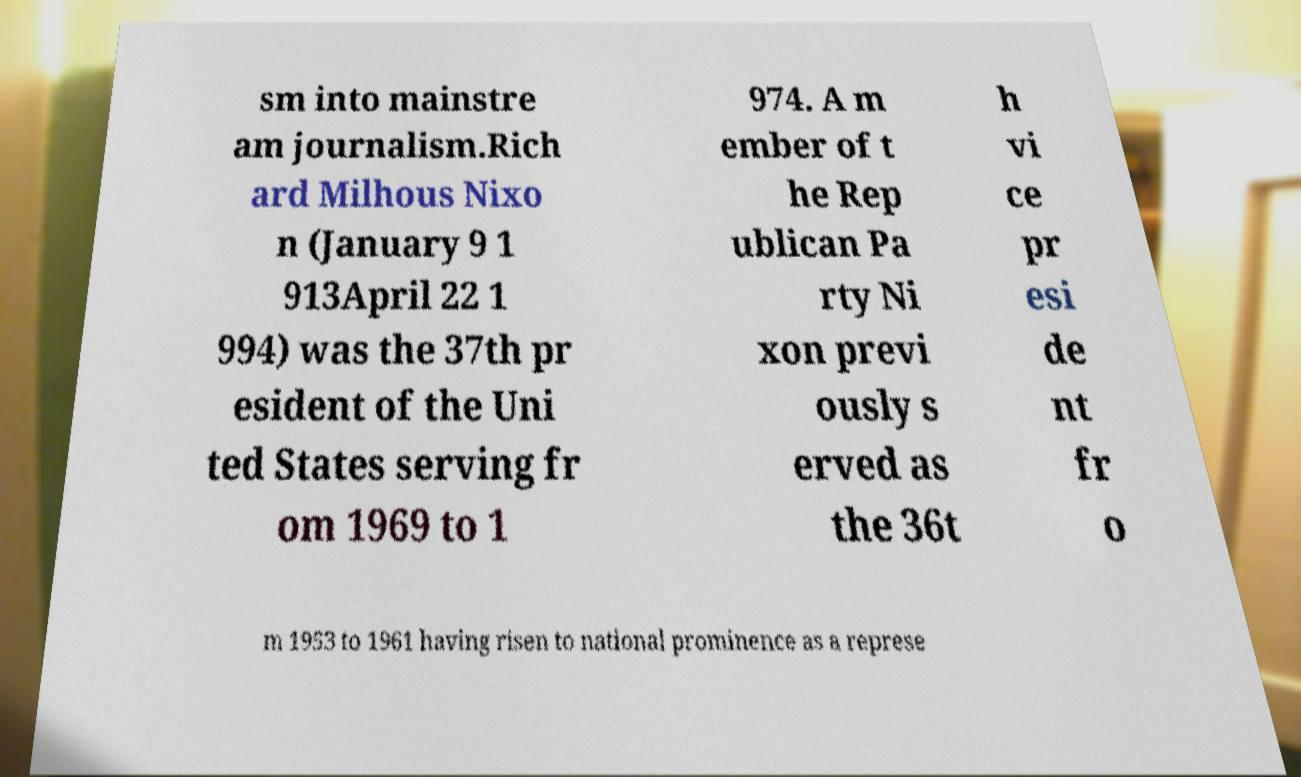For documentation purposes, I need the text within this image transcribed. Could you provide that? sm into mainstre am journalism.Rich ard Milhous Nixo n (January 9 1 913April 22 1 994) was the 37th pr esident of the Uni ted States serving fr om 1969 to 1 974. A m ember of t he Rep ublican Pa rty Ni xon previ ously s erved as the 36t h vi ce pr esi de nt fr o m 1953 to 1961 having risen to national prominence as a represe 